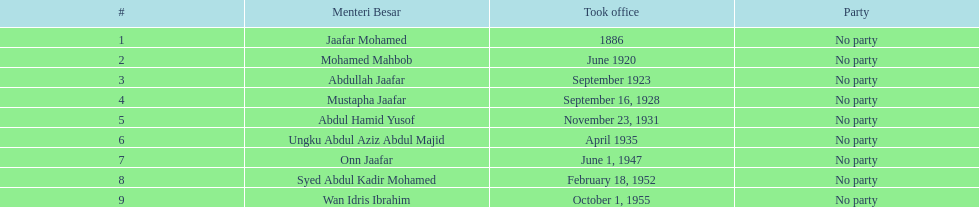Who was in office after mustapha jaafar Abdul Hamid Yusof. 